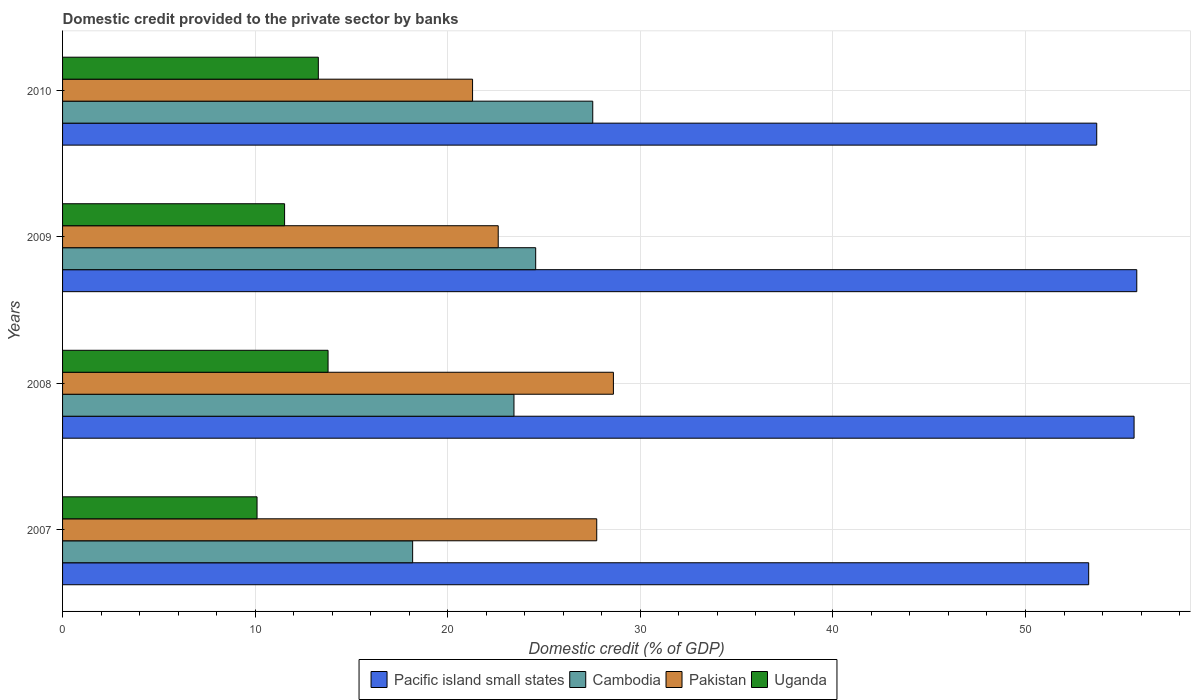How many different coloured bars are there?
Your answer should be compact. 4. How many groups of bars are there?
Make the answer very short. 4. Are the number of bars per tick equal to the number of legend labels?
Make the answer very short. Yes. How many bars are there on the 1st tick from the top?
Make the answer very short. 4. How many bars are there on the 3rd tick from the bottom?
Keep it short and to the point. 4. What is the label of the 4th group of bars from the top?
Provide a succinct answer. 2007. What is the domestic credit provided to the private sector by banks in Uganda in 2007?
Your response must be concise. 10.1. Across all years, what is the maximum domestic credit provided to the private sector by banks in Pakistan?
Give a very brief answer. 28.6. Across all years, what is the minimum domestic credit provided to the private sector by banks in Uganda?
Provide a succinct answer. 10.1. In which year was the domestic credit provided to the private sector by banks in Pacific island small states maximum?
Offer a very short reply. 2009. In which year was the domestic credit provided to the private sector by banks in Pacific island small states minimum?
Your response must be concise. 2007. What is the total domestic credit provided to the private sector by banks in Pakistan in the graph?
Your answer should be very brief. 100.25. What is the difference between the domestic credit provided to the private sector by banks in Uganda in 2007 and that in 2008?
Provide a short and direct response. -3.69. What is the difference between the domestic credit provided to the private sector by banks in Pacific island small states in 2010 and the domestic credit provided to the private sector by banks in Cambodia in 2008?
Provide a succinct answer. 30.26. What is the average domestic credit provided to the private sector by banks in Pakistan per year?
Your answer should be very brief. 25.06. In the year 2009, what is the difference between the domestic credit provided to the private sector by banks in Pakistan and domestic credit provided to the private sector by banks in Uganda?
Keep it short and to the point. 11.09. What is the ratio of the domestic credit provided to the private sector by banks in Cambodia in 2007 to that in 2009?
Give a very brief answer. 0.74. Is the domestic credit provided to the private sector by banks in Pakistan in 2007 less than that in 2010?
Ensure brevity in your answer.  No. Is the difference between the domestic credit provided to the private sector by banks in Pakistan in 2007 and 2009 greater than the difference between the domestic credit provided to the private sector by banks in Uganda in 2007 and 2009?
Keep it short and to the point. Yes. What is the difference between the highest and the second highest domestic credit provided to the private sector by banks in Uganda?
Your answer should be compact. 0.51. What is the difference between the highest and the lowest domestic credit provided to the private sector by banks in Cambodia?
Keep it short and to the point. 9.35. In how many years, is the domestic credit provided to the private sector by banks in Uganda greater than the average domestic credit provided to the private sector by banks in Uganda taken over all years?
Your answer should be very brief. 2. Is it the case that in every year, the sum of the domestic credit provided to the private sector by banks in Pakistan and domestic credit provided to the private sector by banks in Pacific island small states is greater than the sum of domestic credit provided to the private sector by banks in Cambodia and domestic credit provided to the private sector by banks in Uganda?
Offer a very short reply. Yes. What does the 4th bar from the top in 2010 represents?
Your answer should be compact. Pacific island small states. What does the 1st bar from the bottom in 2008 represents?
Ensure brevity in your answer.  Pacific island small states. How many years are there in the graph?
Your answer should be compact. 4. Are the values on the major ticks of X-axis written in scientific E-notation?
Give a very brief answer. No. Does the graph contain grids?
Provide a succinct answer. Yes. Where does the legend appear in the graph?
Your answer should be very brief. Bottom center. What is the title of the graph?
Keep it short and to the point. Domestic credit provided to the private sector by banks. What is the label or title of the X-axis?
Keep it short and to the point. Domestic credit (% of GDP). What is the Domestic credit (% of GDP) of Pacific island small states in 2007?
Give a very brief answer. 53.28. What is the Domestic credit (% of GDP) in Cambodia in 2007?
Your answer should be very brief. 18.18. What is the Domestic credit (% of GDP) in Pakistan in 2007?
Your answer should be compact. 27.74. What is the Domestic credit (% of GDP) in Uganda in 2007?
Offer a very short reply. 10.1. What is the Domestic credit (% of GDP) in Pacific island small states in 2008?
Provide a short and direct response. 55.64. What is the Domestic credit (% of GDP) of Cambodia in 2008?
Make the answer very short. 23.44. What is the Domestic credit (% of GDP) in Pakistan in 2008?
Offer a terse response. 28.6. What is the Domestic credit (% of GDP) in Uganda in 2008?
Offer a very short reply. 13.79. What is the Domestic credit (% of GDP) in Pacific island small states in 2009?
Provide a succinct answer. 55.78. What is the Domestic credit (% of GDP) in Cambodia in 2009?
Keep it short and to the point. 24.57. What is the Domestic credit (% of GDP) in Pakistan in 2009?
Offer a very short reply. 22.62. What is the Domestic credit (% of GDP) of Uganda in 2009?
Your answer should be compact. 11.53. What is the Domestic credit (% of GDP) in Pacific island small states in 2010?
Keep it short and to the point. 53.7. What is the Domestic credit (% of GDP) of Cambodia in 2010?
Offer a very short reply. 27.53. What is the Domestic credit (% of GDP) of Pakistan in 2010?
Your answer should be compact. 21.29. What is the Domestic credit (% of GDP) in Uganda in 2010?
Keep it short and to the point. 13.28. Across all years, what is the maximum Domestic credit (% of GDP) in Pacific island small states?
Provide a short and direct response. 55.78. Across all years, what is the maximum Domestic credit (% of GDP) in Cambodia?
Your answer should be compact. 27.53. Across all years, what is the maximum Domestic credit (% of GDP) in Pakistan?
Keep it short and to the point. 28.6. Across all years, what is the maximum Domestic credit (% of GDP) in Uganda?
Your answer should be very brief. 13.79. Across all years, what is the minimum Domestic credit (% of GDP) in Pacific island small states?
Your answer should be compact. 53.28. Across all years, what is the minimum Domestic credit (% of GDP) in Cambodia?
Offer a very short reply. 18.18. Across all years, what is the minimum Domestic credit (% of GDP) of Pakistan?
Offer a terse response. 21.29. Across all years, what is the minimum Domestic credit (% of GDP) in Uganda?
Your response must be concise. 10.1. What is the total Domestic credit (% of GDP) in Pacific island small states in the graph?
Offer a very short reply. 218.4. What is the total Domestic credit (% of GDP) in Cambodia in the graph?
Offer a terse response. 93.71. What is the total Domestic credit (% of GDP) of Pakistan in the graph?
Keep it short and to the point. 100.25. What is the total Domestic credit (% of GDP) of Uganda in the graph?
Your response must be concise. 48.69. What is the difference between the Domestic credit (% of GDP) of Pacific island small states in 2007 and that in 2008?
Give a very brief answer. -2.36. What is the difference between the Domestic credit (% of GDP) in Cambodia in 2007 and that in 2008?
Your response must be concise. -5.26. What is the difference between the Domestic credit (% of GDP) in Pakistan in 2007 and that in 2008?
Make the answer very short. -0.87. What is the difference between the Domestic credit (% of GDP) in Uganda in 2007 and that in 2008?
Your answer should be compact. -3.69. What is the difference between the Domestic credit (% of GDP) in Pacific island small states in 2007 and that in 2009?
Offer a very short reply. -2.5. What is the difference between the Domestic credit (% of GDP) of Cambodia in 2007 and that in 2009?
Make the answer very short. -6.39. What is the difference between the Domestic credit (% of GDP) of Pakistan in 2007 and that in 2009?
Keep it short and to the point. 5.12. What is the difference between the Domestic credit (% of GDP) in Uganda in 2007 and that in 2009?
Offer a very short reply. -1.43. What is the difference between the Domestic credit (% of GDP) of Pacific island small states in 2007 and that in 2010?
Offer a terse response. -0.42. What is the difference between the Domestic credit (% of GDP) in Cambodia in 2007 and that in 2010?
Your answer should be very brief. -9.35. What is the difference between the Domestic credit (% of GDP) in Pakistan in 2007 and that in 2010?
Ensure brevity in your answer.  6.45. What is the difference between the Domestic credit (% of GDP) in Uganda in 2007 and that in 2010?
Your response must be concise. -3.18. What is the difference between the Domestic credit (% of GDP) in Pacific island small states in 2008 and that in 2009?
Your response must be concise. -0.14. What is the difference between the Domestic credit (% of GDP) in Cambodia in 2008 and that in 2009?
Your response must be concise. -1.13. What is the difference between the Domestic credit (% of GDP) of Pakistan in 2008 and that in 2009?
Your answer should be compact. 5.98. What is the difference between the Domestic credit (% of GDP) of Uganda in 2008 and that in 2009?
Provide a short and direct response. 2.26. What is the difference between the Domestic credit (% of GDP) of Pacific island small states in 2008 and that in 2010?
Offer a very short reply. 1.94. What is the difference between the Domestic credit (% of GDP) of Cambodia in 2008 and that in 2010?
Make the answer very short. -4.09. What is the difference between the Domestic credit (% of GDP) of Pakistan in 2008 and that in 2010?
Provide a succinct answer. 7.31. What is the difference between the Domestic credit (% of GDP) in Uganda in 2008 and that in 2010?
Give a very brief answer. 0.51. What is the difference between the Domestic credit (% of GDP) in Pacific island small states in 2009 and that in 2010?
Keep it short and to the point. 2.08. What is the difference between the Domestic credit (% of GDP) of Cambodia in 2009 and that in 2010?
Provide a succinct answer. -2.96. What is the difference between the Domestic credit (% of GDP) in Pakistan in 2009 and that in 2010?
Your response must be concise. 1.33. What is the difference between the Domestic credit (% of GDP) of Uganda in 2009 and that in 2010?
Keep it short and to the point. -1.75. What is the difference between the Domestic credit (% of GDP) in Pacific island small states in 2007 and the Domestic credit (% of GDP) in Cambodia in 2008?
Ensure brevity in your answer.  29.84. What is the difference between the Domestic credit (% of GDP) in Pacific island small states in 2007 and the Domestic credit (% of GDP) in Pakistan in 2008?
Your answer should be very brief. 24.68. What is the difference between the Domestic credit (% of GDP) of Pacific island small states in 2007 and the Domestic credit (% of GDP) of Uganda in 2008?
Your answer should be compact. 39.5. What is the difference between the Domestic credit (% of GDP) of Cambodia in 2007 and the Domestic credit (% of GDP) of Pakistan in 2008?
Your answer should be compact. -10.43. What is the difference between the Domestic credit (% of GDP) of Cambodia in 2007 and the Domestic credit (% of GDP) of Uganda in 2008?
Offer a very short reply. 4.39. What is the difference between the Domestic credit (% of GDP) in Pakistan in 2007 and the Domestic credit (% of GDP) in Uganda in 2008?
Ensure brevity in your answer.  13.95. What is the difference between the Domestic credit (% of GDP) in Pacific island small states in 2007 and the Domestic credit (% of GDP) in Cambodia in 2009?
Your answer should be compact. 28.71. What is the difference between the Domestic credit (% of GDP) in Pacific island small states in 2007 and the Domestic credit (% of GDP) in Pakistan in 2009?
Your response must be concise. 30.66. What is the difference between the Domestic credit (% of GDP) of Pacific island small states in 2007 and the Domestic credit (% of GDP) of Uganda in 2009?
Offer a very short reply. 41.75. What is the difference between the Domestic credit (% of GDP) of Cambodia in 2007 and the Domestic credit (% of GDP) of Pakistan in 2009?
Ensure brevity in your answer.  -4.44. What is the difference between the Domestic credit (% of GDP) in Cambodia in 2007 and the Domestic credit (% of GDP) in Uganda in 2009?
Offer a very short reply. 6.65. What is the difference between the Domestic credit (% of GDP) in Pakistan in 2007 and the Domestic credit (% of GDP) in Uganda in 2009?
Your response must be concise. 16.21. What is the difference between the Domestic credit (% of GDP) in Pacific island small states in 2007 and the Domestic credit (% of GDP) in Cambodia in 2010?
Your answer should be very brief. 25.75. What is the difference between the Domestic credit (% of GDP) of Pacific island small states in 2007 and the Domestic credit (% of GDP) of Pakistan in 2010?
Provide a short and direct response. 31.99. What is the difference between the Domestic credit (% of GDP) of Pacific island small states in 2007 and the Domestic credit (% of GDP) of Uganda in 2010?
Offer a very short reply. 40. What is the difference between the Domestic credit (% of GDP) of Cambodia in 2007 and the Domestic credit (% of GDP) of Pakistan in 2010?
Give a very brief answer. -3.11. What is the difference between the Domestic credit (% of GDP) of Cambodia in 2007 and the Domestic credit (% of GDP) of Uganda in 2010?
Provide a succinct answer. 4.9. What is the difference between the Domestic credit (% of GDP) in Pakistan in 2007 and the Domestic credit (% of GDP) in Uganda in 2010?
Ensure brevity in your answer.  14.46. What is the difference between the Domestic credit (% of GDP) in Pacific island small states in 2008 and the Domestic credit (% of GDP) in Cambodia in 2009?
Offer a very short reply. 31.07. What is the difference between the Domestic credit (% of GDP) of Pacific island small states in 2008 and the Domestic credit (% of GDP) of Pakistan in 2009?
Provide a succinct answer. 33.02. What is the difference between the Domestic credit (% of GDP) in Pacific island small states in 2008 and the Domestic credit (% of GDP) in Uganda in 2009?
Keep it short and to the point. 44.11. What is the difference between the Domestic credit (% of GDP) of Cambodia in 2008 and the Domestic credit (% of GDP) of Pakistan in 2009?
Offer a terse response. 0.82. What is the difference between the Domestic credit (% of GDP) in Cambodia in 2008 and the Domestic credit (% of GDP) in Uganda in 2009?
Offer a very short reply. 11.91. What is the difference between the Domestic credit (% of GDP) of Pakistan in 2008 and the Domestic credit (% of GDP) of Uganda in 2009?
Provide a succinct answer. 17.07. What is the difference between the Domestic credit (% of GDP) in Pacific island small states in 2008 and the Domestic credit (% of GDP) in Cambodia in 2010?
Keep it short and to the point. 28.11. What is the difference between the Domestic credit (% of GDP) in Pacific island small states in 2008 and the Domestic credit (% of GDP) in Pakistan in 2010?
Offer a very short reply. 34.35. What is the difference between the Domestic credit (% of GDP) of Pacific island small states in 2008 and the Domestic credit (% of GDP) of Uganda in 2010?
Keep it short and to the point. 42.36. What is the difference between the Domestic credit (% of GDP) in Cambodia in 2008 and the Domestic credit (% of GDP) in Pakistan in 2010?
Give a very brief answer. 2.15. What is the difference between the Domestic credit (% of GDP) of Cambodia in 2008 and the Domestic credit (% of GDP) of Uganda in 2010?
Your answer should be compact. 10.16. What is the difference between the Domestic credit (% of GDP) in Pakistan in 2008 and the Domestic credit (% of GDP) in Uganda in 2010?
Offer a very short reply. 15.32. What is the difference between the Domestic credit (% of GDP) of Pacific island small states in 2009 and the Domestic credit (% of GDP) of Cambodia in 2010?
Keep it short and to the point. 28.25. What is the difference between the Domestic credit (% of GDP) of Pacific island small states in 2009 and the Domestic credit (% of GDP) of Pakistan in 2010?
Keep it short and to the point. 34.49. What is the difference between the Domestic credit (% of GDP) in Pacific island small states in 2009 and the Domestic credit (% of GDP) in Uganda in 2010?
Offer a very short reply. 42.5. What is the difference between the Domestic credit (% of GDP) of Cambodia in 2009 and the Domestic credit (% of GDP) of Pakistan in 2010?
Offer a terse response. 3.28. What is the difference between the Domestic credit (% of GDP) in Cambodia in 2009 and the Domestic credit (% of GDP) in Uganda in 2010?
Your response must be concise. 11.29. What is the difference between the Domestic credit (% of GDP) in Pakistan in 2009 and the Domestic credit (% of GDP) in Uganda in 2010?
Give a very brief answer. 9.34. What is the average Domestic credit (% of GDP) in Pacific island small states per year?
Your answer should be compact. 54.6. What is the average Domestic credit (% of GDP) in Cambodia per year?
Ensure brevity in your answer.  23.43. What is the average Domestic credit (% of GDP) in Pakistan per year?
Your answer should be very brief. 25.06. What is the average Domestic credit (% of GDP) of Uganda per year?
Provide a succinct answer. 12.17. In the year 2007, what is the difference between the Domestic credit (% of GDP) in Pacific island small states and Domestic credit (% of GDP) in Cambodia?
Provide a short and direct response. 35.1. In the year 2007, what is the difference between the Domestic credit (% of GDP) of Pacific island small states and Domestic credit (% of GDP) of Pakistan?
Ensure brevity in your answer.  25.54. In the year 2007, what is the difference between the Domestic credit (% of GDP) of Pacific island small states and Domestic credit (% of GDP) of Uganda?
Give a very brief answer. 43.18. In the year 2007, what is the difference between the Domestic credit (% of GDP) in Cambodia and Domestic credit (% of GDP) in Pakistan?
Provide a succinct answer. -9.56. In the year 2007, what is the difference between the Domestic credit (% of GDP) in Cambodia and Domestic credit (% of GDP) in Uganda?
Make the answer very short. 8.08. In the year 2007, what is the difference between the Domestic credit (% of GDP) in Pakistan and Domestic credit (% of GDP) in Uganda?
Your answer should be very brief. 17.64. In the year 2008, what is the difference between the Domestic credit (% of GDP) of Pacific island small states and Domestic credit (% of GDP) of Cambodia?
Provide a short and direct response. 32.2. In the year 2008, what is the difference between the Domestic credit (% of GDP) of Pacific island small states and Domestic credit (% of GDP) of Pakistan?
Keep it short and to the point. 27.04. In the year 2008, what is the difference between the Domestic credit (% of GDP) in Pacific island small states and Domestic credit (% of GDP) in Uganda?
Your answer should be very brief. 41.85. In the year 2008, what is the difference between the Domestic credit (% of GDP) in Cambodia and Domestic credit (% of GDP) in Pakistan?
Ensure brevity in your answer.  -5.16. In the year 2008, what is the difference between the Domestic credit (% of GDP) in Cambodia and Domestic credit (% of GDP) in Uganda?
Make the answer very short. 9.65. In the year 2008, what is the difference between the Domestic credit (% of GDP) of Pakistan and Domestic credit (% of GDP) of Uganda?
Provide a succinct answer. 14.82. In the year 2009, what is the difference between the Domestic credit (% of GDP) of Pacific island small states and Domestic credit (% of GDP) of Cambodia?
Ensure brevity in your answer.  31.21. In the year 2009, what is the difference between the Domestic credit (% of GDP) of Pacific island small states and Domestic credit (% of GDP) of Pakistan?
Provide a succinct answer. 33.16. In the year 2009, what is the difference between the Domestic credit (% of GDP) in Pacific island small states and Domestic credit (% of GDP) in Uganda?
Give a very brief answer. 44.25. In the year 2009, what is the difference between the Domestic credit (% of GDP) of Cambodia and Domestic credit (% of GDP) of Pakistan?
Give a very brief answer. 1.95. In the year 2009, what is the difference between the Domestic credit (% of GDP) of Cambodia and Domestic credit (% of GDP) of Uganda?
Your response must be concise. 13.04. In the year 2009, what is the difference between the Domestic credit (% of GDP) of Pakistan and Domestic credit (% of GDP) of Uganda?
Provide a short and direct response. 11.09. In the year 2010, what is the difference between the Domestic credit (% of GDP) of Pacific island small states and Domestic credit (% of GDP) of Cambodia?
Make the answer very short. 26.17. In the year 2010, what is the difference between the Domestic credit (% of GDP) in Pacific island small states and Domestic credit (% of GDP) in Pakistan?
Provide a succinct answer. 32.41. In the year 2010, what is the difference between the Domestic credit (% of GDP) in Pacific island small states and Domestic credit (% of GDP) in Uganda?
Make the answer very short. 40.42. In the year 2010, what is the difference between the Domestic credit (% of GDP) of Cambodia and Domestic credit (% of GDP) of Pakistan?
Offer a terse response. 6.24. In the year 2010, what is the difference between the Domestic credit (% of GDP) of Cambodia and Domestic credit (% of GDP) of Uganda?
Ensure brevity in your answer.  14.25. In the year 2010, what is the difference between the Domestic credit (% of GDP) of Pakistan and Domestic credit (% of GDP) of Uganda?
Ensure brevity in your answer.  8.01. What is the ratio of the Domestic credit (% of GDP) in Pacific island small states in 2007 to that in 2008?
Provide a short and direct response. 0.96. What is the ratio of the Domestic credit (% of GDP) of Cambodia in 2007 to that in 2008?
Provide a short and direct response. 0.78. What is the ratio of the Domestic credit (% of GDP) in Pakistan in 2007 to that in 2008?
Your response must be concise. 0.97. What is the ratio of the Domestic credit (% of GDP) of Uganda in 2007 to that in 2008?
Provide a short and direct response. 0.73. What is the ratio of the Domestic credit (% of GDP) of Pacific island small states in 2007 to that in 2009?
Offer a very short reply. 0.96. What is the ratio of the Domestic credit (% of GDP) in Cambodia in 2007 to that in 2009?
Give a very brief answer. 0.74. What is the ratio of the Domestic credit (% of GDP) of Pakistan in 2007 to that in 2009?
Ensure brevity in your answer.  1.23. What is the ratio of the Domestic credit (% of GDP) in Uganda in 2007 to that in 2009?
Offer a very short reply. 0.88. What is the ratio of the Domestic credit (% of GDP) of Pacific island small states in 2007 to that in 2010?
Make the answer very short. 0.99. What is the ratio of the Domestic credit (% of GDP) in Cambodia in 2007 to that in 2010?
Keep it short and to the point. 0.66. What is the ratio of the Domestic credit (% of GDP) of Pakistan in 2007 to that in 2010?
Provide a succinct answer. 1.3. What is the ratio of the Domestic credit (% of GDP) in Uganda in 2007 to that in 2010?
Offer a very short reply. 0.76. What is the ratio of the Domestic credit (% of GDP) in Cambodia in 2008 to that in 2009?
Make the answer very short. 0.95. What is the ratio of the Domestic credit (% of GDP) in Pakistan in 2008 to that in 2009?
Provide a succinct answer. 1.26. What is the ratio of the Domestic credit (% of GDP) in Uganda in 2008 to that in 2009?
Provide a succinct answer. 1.2. What is the ratio of the Domestic credit (% of GDP) in Pacific island small states in 2008 to that in 2010?
Keep it short and to the point. 1.04. What is the ratio of the Domestic credit (% of GDP) in Cambodia in 2008 to that in 2010?
Keep it short and to the point. 0.85. What is the ratio of the Domestic credit (% of GDP) of Pakistan in 2008 to that in 2010?
Keep it short and to the point. 1.34. What is the ratio of the Domestic credit (% of GDP) of Uganda in 2008 to that in 2010?
Make the answer very short. 1.04. What is the ratio of the Domestic credit (% of GDP) in Pacific island small states in 2009 to that in 2010?
Give a very brief answer. 1.04. What is the ratio of the Domestic credit (% of GDP) of Cambodia in 2009 to that in 2010?
Offer a very short reply. 0.89. What is the ratio of the Domestic credit (% of GDP) in Pakistan in 2009 to that in 2010?
Offer a very short reply. 1.06. What is the ratio of the Domestic credit (% of GDP) of Uganda in 2009 to that in 2010?
Your response must be concise. 0.87. What is the difference between the highest and the second highest Domestic credit (% of GDP) of Pacific island small states?
Your answer should be compact. 0.14. What is the difference between the highest and the second highest Domestic credit (% of GDP) of Cambodia?
Offer a terse response. 2.96. What is the difference between the highest and the second highest Domestic credit (% of GDP) in Pakistan?
Your answer should be compact. 0.87. What is the difference between the highest and the second highest Domestic credit (% of GDP) of Uganda?
Provide a succinct answer. 0.51. What is the difference between the highest and the lowest Domestic credit (% of GDP) in Pacific island small states?
Offer a very short reply. 2.5. What is the difference between the highest and the lowest Domestic credit (% of GDP) of Cambodia?
Your answer should be compact. 9.35. What is the difference between the highest and the lowest Domestic credit (% of GDP) of Pakistan?
Provide a short and direct response. 7.31. What is the difference between the highest and the lowest Domestic credit (% of GDP) of Uganda?
Make the answer very short. 3.69. 